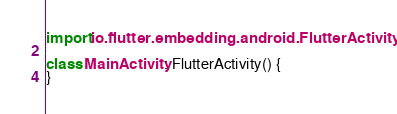Convert code to text. <code><loc_0><loc_0><loc_500><loc_500><_Kotlin_>
import io.flutter.embedding.android.FlutterActivity

class MainActivity: FlutterActivity() {
}
</code> 